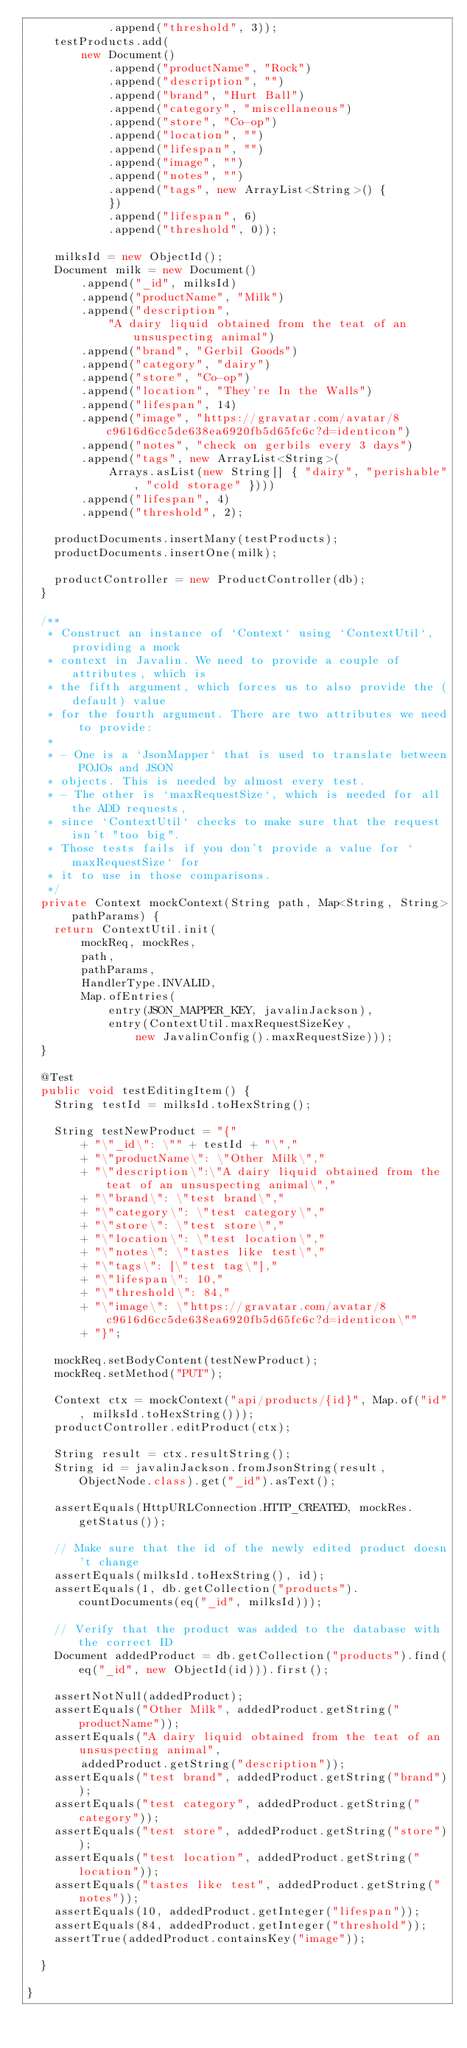Convert code to text. <code><loc_0><loc_0><loc_500><loc_500><_Java_>            .append("threshold", 3));
    testProducts.add(
        new Document()
            .append("productName", "Rock")
            .append("description", "")
            .append("brand", "Hurt Ball")
            .append("category", "miscellaneous")
            .append("store", "Co-op")
            .append("location", "")
            .append("lifespan", "")
            .append("image", "")
            .append("notes", "")
            .append("tags", new ArrayList<String>() {
            })
            .append("lifespan", 6)
            .append("threshold", 0));

    milksId = new ObjectId();
    Document milk = new Document()
        .append("_id", milksId)
        .append("productName", "Milk")
        .append("description",
            "A dairy liquid obtained from the teat of an unsuspecting animal")
        .append("brand", "Gerbil Goods")
        .append("category", "dairy")
        .append("store", "Co-op")
        .append("location", "They're In the Walls")
        .append("lifespan", 14)
        .append("image", "https://gravatar.com/avatar/8c9616d6cc5de638ea6920fb5d65fc6c?d=identicon")
        .append("notes", "check on gerbils every 3 days")
        .append("tags", new ArrayList<String>(
            Arrays.asList(new String[] { "dairy", "perishable", "cold storage" })))
        .append("lifespan", 4)
        .append("threshold", 2);

    productDocuments.insertMany(testProducts);
    productDocuments.insertOne(milk);

    productController = new ProductController(db);
  }

  /**
   * Construct an instance of `Context` using `ContextUtil`, providing a mock
   * context in Javalin. We need to provide a couple of attributes, which is
   * the fifth argument, which forces us to also provide the (default) value
   * for the fourth argument. There are two attributes we need to provide:
   *
   * - One is a `JsonMapper` that is used to translate between POJOs and JSON
   * objects. This is needed by almost every test.
   * - The other is `maxRequestSize`, which is needed for all the ADD requests,
   * since `ContextUtil` checks to make sure that the request isn't "too big".
   * Those tests fails if you don't provide a value for `maxRequestSize` for
   * it to use in those comparisons.
   */
  private Context mockContext(String path, Map<String, String> pathParams) {
    return ContextUtil.init(
        mockReq, mockRes,
        path,
        pathParams,
        HandlerType.INVALID,
        Map.ofEntries(
            entry(JSON_MAPPER_KEY, javalinJackson),
            entry(ContextUtil.maxRequestSizeKey,
                new JavalinConfig().maxRequestSize)));
  }

  @Test
  public void testEditingItem() {
    String testId = milksId.toHexString();

    String testNewProduct = "{"
        + "\"_id\": \"" + testId + "\","
        + "\"productName\": \"Other Milk\","
        + "\"description\":\"A dairy liquid obtained from the teat of an unsuspecting animal\","
        + "\"brand\": \"test brand\","
        + "\"category\": \"test category\","
        + "\"store\": \"test store\","
        + "\"location\": \"test location\","
        + "\"notes\": \"tastes like test\","
        + "\"tags\": [\"test tag\"],"
        + "\"lifespan\": 10,"
        + "\"threshold\": 84,"
        + "\"image\": \"https://gravatar.com/avatar/8c9616d6cc5de638ea6920fb5d65fc6c?d=identicon\""
        + "}";

    mockReq.setBodyContent(testNewProduct);
    mockReq.setMethod("PUT");

    Context ctx = mockContext("api/products/{id}", Map.of("id", milksId.toHexString()));
    productController.editProduct(ctx);

    String result = ctx.resultString();
    String id = javalinJackson.fromJsonString(result, ObjectNode.class).get("_id").asText();

    assertEquals(HttpURLConnection.HTTP_CREATED, mockRes.getStatus());

    // Make sure that the id of the newly edited product doesn't change
    assertEquals(milksId.toHexString(), id);
    assertEquals(1, db.getCollection("products").countDocuments(eq("_id", milksId)));

    // Verify that the product was added to the database with the correct ID
    Document addedProduct = db.getCollection("products").find(eq("_id", new ObjectId(id))).first();

    assertNotNull(addedProduct);
    assertEquals("Other Milk", addedProduct.getString("productName"));
    assertEquals("A dairy liquid obtained from the teat of an unsuspecting animal",
        addedProduct.getString("description"));
    assertEquals("test brand", addedProduct.getString("brand"));
    assertEquals("test category", addedProduct.getString("category"));
    assertEquals("test store", addedProduct.getString("store"));
    assertEquals("test location", addedProduct.getString("location"));
    assertEquals("tastes like test", addedProduct.getString("notes"));
    assertEquals(10, addedProduct.getInteger("lifespan"));
    assertEquals(84, addedProduct.getInteger("threshold"));
    assertTrue(addedProduct.containsKey("image"));

  }

}
</code> 